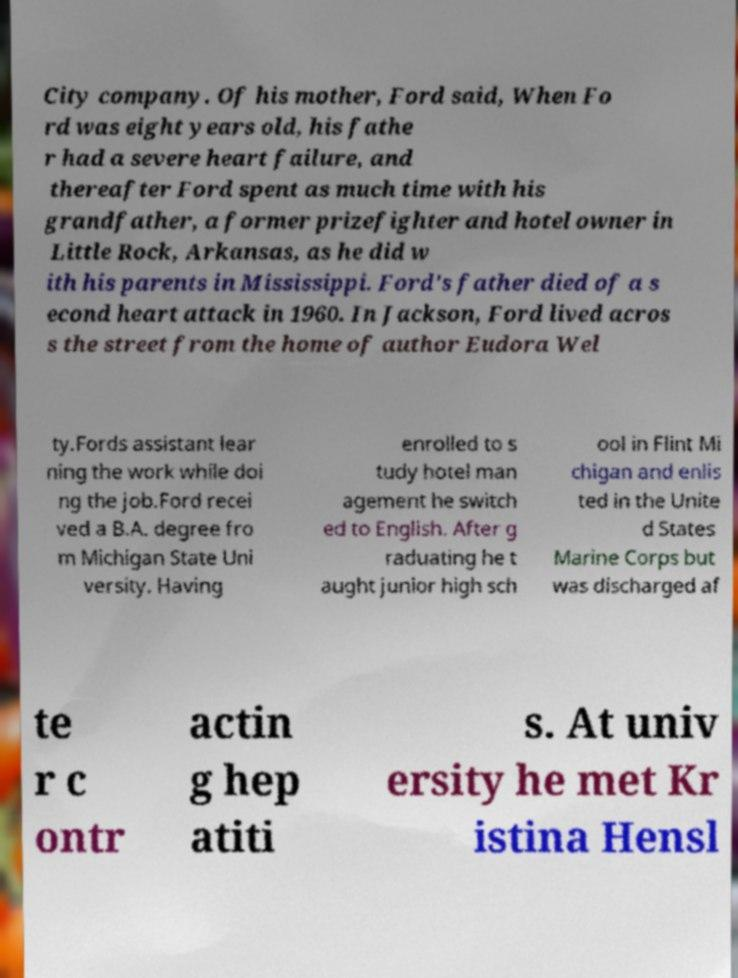Could you extract and type out the text from this image? City company. Of his mother, Ford said, When Fo rd was eight years old, his fathe r had a severe heart failure, and thereafter Ford spent as much time with his grandfather, a former prizefighter and hotel owner in Little Rock, Arkansas, as he did w ith his parents in Mississippi. Ford's father died of a s econd heart attack in 1960. In Jackson, Ford lived acros s the street from the home of author Eudora Wel ty.Fords assistant lear ning the work while doi ng the job.Ford recei ved a B.A. degree fro m Michigan State Uni versity. Having enrolled to s tudy hotel man agement he switch ed to English. After g raduating he t aught junior high sch ool in Flint Mi chigan and enlis ted in the Unite d States Marine Corps but was discharged af te r c ontr actin g hep atiti s. At univ ersity he met Kr istina Hensl 